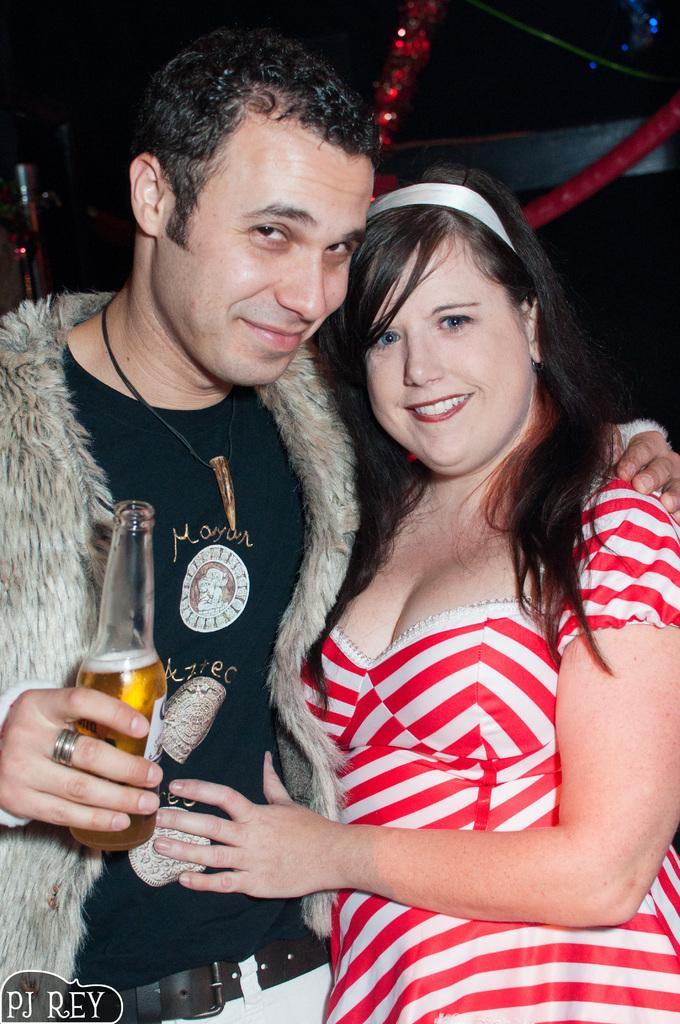How many people are in the image? There are two persons in the image. What are the positions of the people in the image? Both persons are standing. What is the man holding in the image? The man is holding a bottle. What type of goose can be seen in the image? There is no goose present in the image. How many cows are visible in the image? There are no cows visible in the image. 